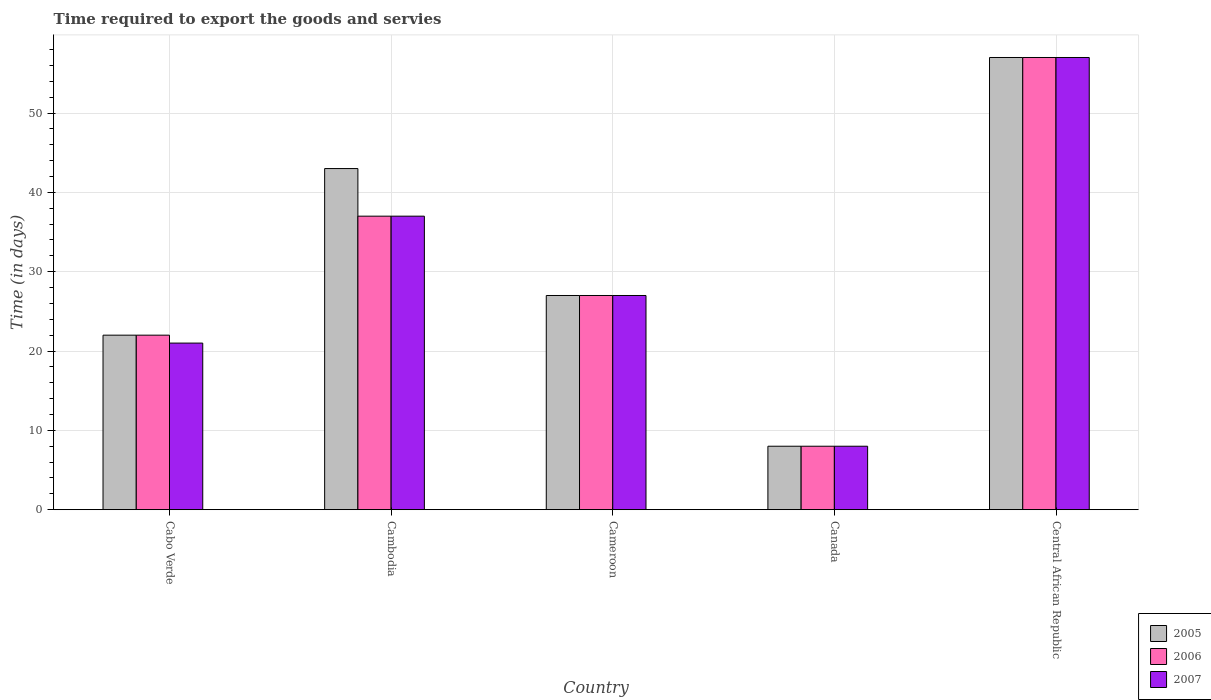How many different coloured bars are there?
Make the answer very short. 3. How many groups of bars are there?
Offer a terse response. 5. Are the number of bars on each tick of the X-axis equal?
Provide a short and direct response. Yes. How many bars are there on the 1st tick from the right?
Offer a very short reply. 3. What is the label of the 2nd group of bars from the left?
Provide a short and direct response. Cambodia. In how many cases, is the number of bars for a given country not equal to the number of legend labels?
Your response must be concise. 0. What is the number of days required to export the goods and services in 2006 in Cabo Verde?
Your answer should be very brief. 22. Across all countries, what is the maximum number of days required to export the goods and services in 2005?
Ensure brevity in your answer.  57. In which country was the number of days required to export the goods and services in 2006 maximum?
Provide a succinct answer. Central African Republic. What is the total number of days required to export the goods and services in 2006 in the graph?
Provide a short and direct response. 151. What is the average number of days required to export the goods and services in 2006 per country?
Give a very brief answer. 30.2. In how many countries, is the number of days required to export the goods and services in 2007 greater than 26 days?
Offer a terse response. 3. What is the ratio of the number of days required to export the goods and services in 2006 in Cabo Verde to that in Cameroon?
Your answer should be very brief. 0.81. Is the difference between the number of days required to export the goods and services in 2007 in Cabo Verde and Canada greater than the difference between the number of days required to export the goods and services in 2005 in Cabo Verde and Canada?
Offer a terse response. No. In how many countries, is the number of days required to export the goods and services in 2005 greater than the average number of days required to export the goods and services in 2005 taken over all countries?
Give a very brief answer. 2. Is it the case that in every country, the sum of the number of days required to export the goods and services in 2006 and number of days required to export the goods and services in 2007 is greater than the number of days required to export the goods and services in 2005?
Give a very brief answer. Yes. What is the difference between two consecutive major ticks on the Y-axis?
Keep it short and to the point. 10. Does the graph contain any zero values?
Your response must be concise. No. How many legend labels are there?
Provide a succinct answer. 3. How are the legend labels stacked?
Offer a terse response. Vertical. What is the title of the graph?
Provide a short and direct response. Time required to export the goods and servies. Does "2001" appear as one of the legend labels in the graph?
Give a very brief answer. No. What is the label or title of the Y-axis?
Your response must be concise. Time (in days). What is the Time (in days) in 2005 in Cabo Verde?
Provide a short and direct response. 22. What is the Time (in days) in 2005 in Cambodia?
Provide a succinct answer. 43. What is the Time (in days) of 2006 in Cambodia?
Ensure brevity in your answer.  37. What is the Time (in days) in 2005 in Cameroon?
Your answer should be compact. 27. What is the Time (in days) in 2006 in Cameroon?
Give a very brief answer. 27. What is the Time (in days) of 2005 in Central African Republic?
Offer a very short reply. 57. What is the Time (in days) in 2007 in Central African Republic?
Give a very brief answer. 57. Across all countries, what is the maximum Time (in days) of 2007?
Offer a very short reply. 57. Across all countries, what is the minimum Time (in days) in 2006?
Your answer should be compact. 8. What is the total Time (in days) of 2005 in the graph?
Make the answer very short. 157. What is the total Time (in days) in 2006 in the graph?
Your answer should be compact. 151. What is the total Time (in days) in 2007 in the graph?
Keep it short and to the point. 150. What is the difference between the Time (in days) in 2006 in Cabo Verde and that in Cambodia?
Provide a succinct answer. -15. What is the difference between the Time (in days) of 2005 in Cabo Verde and that in Cameroon?
Keep it short and to the point. -5. What is the difference between the Time (in days) of 2005 in Cabo Verde and that in Canada?
Provide a short and direct response. 14. What is the difference between the Time (in days) of 2006 in Cabo Verde and that in Canada?
Offer a terse response. 14. What is the difference between the Time (in days) of 2005 in Cabo Verde and that in Central African Republic?
Your answer should be very brief. -35. What is the difference between the Time (in days) in 2006 in Cabo Verde and that in Central African Republic?
Your answer should be compact. -35. What is the difference between the Time (in days) in 2007 in Cabo Verde and that in Central African Republic?
Offer a terse response. -36. What is the difference between the Time (in days) of 2005 in Cambodia and that in Cameroon?
Offer a terse response. 16. What is the difference between the Time (in days) of 2006 in Cambodia and that in Cameroon?
Offer a very short reply. 10. What is the difference between the Time (in days) of 2006 in Cambodia and that in Canada?
Your answer should be very brief. 29. What is the difference between the Time (in days) of 2005 in Cambodia and that in Central African Republic?
Offer a terse response. -14. What is the difference between the Time (in days) of 2006 in Cambodia and that in Central African Republic?
Your response must be concise. -20. What is the difference between the Time (in days) in 2005 in Cameroon and that in Canada?
Your response must be concise. 19. What is the difference between the Time (in days) in 2006 in Cameroon and that in Canada?
Offer a terse response. 19. What is the difference between the Time (in days) of 2005 in Cameroon and that in Central African Republic?
Provide a succinct answer. -30. What is the difference between the Time (in days) of 2005 in Canada and that in Central African Republic?
Ensure brevity in your answer.  -49. What is the difference between the Time (in days) in 2006 in Canada and that in Central African Republic?
Offer a very short reply. -49. What is the difference between the Time (in days) in 2007 in Canada and that in Central African Republic?
Your answer should be compact. -49. What is the difference between the Time (in days) in 2005 in Cabo Verde and the Time (in days) in 2007 in Cambodia?
Make the answer very short. -15. What is the difference between the Time (in days) in 2006 in Cabo Verde and the Time (in days) in 2007 in Cambodia?
Your answer should be very brief. -15. What is the difference between the Time (in days) of 2005 in Cabo Verde and the Time (in days) of 2007 in Cameroon?
Your response must be concise. -5. What is the difference between the Time (in days) in 2005 in Cabo Verde and the Time (in days) in 2006 in Canada?
Provide a short and direct response. 14. What is the difference between the Time (in days) of 2005 in Cabo Verde and the Time (in days) of 2007 in Canada?
Ensure brevity in your answer.  14. What is the difference between the Time (in days) in 2006 in Cabo Verde and the Time (in days) in 2007 in Canada?
Ensure brevity in your answer.  14. What is the difference between the Time (in days) of 2005 in Cabo Verde and the Time (in days) of 2006 in Central African Republic?
Your answer should be compact. -35. What is the difference between the Time (in days) in 2005 in Cabo Verde and the Time (in days) in 2007 in Central African Republic?
Provide a succinct answer. -35. What is the difference between the Time (in days) in 2006 in Cabo Verde and the Time (in days) in 2007 in Central African Republic?
Provide a short and direct response. -35. What is the difference between the Time (in days) in 2005 in Cambodia and the Time (in days) in 2007 in Cameroon?
Offer a terse response. 16. What is the difference between the Time (in days) of 2006 in Cambodia and the Time (in days) of 2007 in Cameroon?
Ensure brevity in your answer.  10. What is the difference between the Time (in days) in 2005 in Cambodia and the Time (in days) in 2006 in Canada?
Provide a short and direct response. 35. What is the difference between the Time (in days) of 2005 in Cambodia and the Time (in days) of 2007 in Canada?
Offer a terse response. 35. What is the difference between the Time (in days) of 2005 in Cambodia and the Time (in days) of 2007 in Central African Republic?
Offer a very short reply. -14. What is the difference between the Time (in days) in 2006 in Cambodia and the Time (in days) in 2007 in Central African Republic?
Your answer should be very brief. -20. What is the difference between the Time (in days) in 2005 in Cameroon and the Time (in days) in 2006 in Central African Republic?
Provide a short and direct response. -30. What is the difference between the Time (in days) in 2005 in Cameroon and the Time (in days) in 2007 in Central African Republic?
Your response must be concise. -30. What is the difference between the Time (in days) in 2005 in Canada and the Time (in days) in 2006 in Central African Republic?
Your answer should be compact. -49. What is the difference between the Time (in days) of 2005 in Canada and the Time (in days) of 2007 in Central African Republic?
Give a very brief answer. -49. What is the difference between the Time (in days) of 2006 in Canada and the Time (in days) of 2007 in Central African Republic?
Your answer should be very brief. -49. What is the average Time (in days) in 2005 per country?
Provide a short and direct response. 31.4. What is the average Time (in days) in 2006 per country?
Offer a terse response. 30.2. What is the average Time (in days) of 2007 per country?
Make the answer very short. 30. What is the difference between the Time (in days) in 2005 and Time (in days) in 2006 in Cabo Verde?
Provide a short and direct response. 0. What is the difference between the Time (in days) of 2006 and Time (in days) of 2007 in Cabo Verde?
Your answer should be compact. 1. What is the difference between the Time (in days) in 2005 and Time (in days) in 2006 in Cambodia?
Give a very brief answer. 6. What is the difference between the Time (in days) of 2005 and Time (in days) of 2007 in Cambodia?
Give a very brief answer. 6. What is the difference between the Time (in days) of 2005 and Time (in days) of 2006 in Cameroon?
Your answer should be compact. 0. What is the difference between the Time (in days) in 2006 and Time (in days) in 2007 in Cameroon?
Provide a succinct answer. 0. What is the difference between the Time (in days) of 2005 and Time (in days) of 2007 in Canada?
Ensure brevity in your answer.  0. What is the difference between the Time (in days) of 2005 and Time (in days) of 2006 in Central African Republic?
Make the answer very short. 0. What is the difference between the Time (in days) in 2005 and Time (in days) in 2007 in Central African Republic?
Your answer should be very brief. 0. What is the ratio of the Time (in days) in 2005 in Cabo Verde to that in Cambodia?
Your answer should be very brief. 0.51. What is the ratio of the Time (in days) of 2006 in Cabo Verde to that in Cambodia?
Offer a terse response. 0.59. What is the ratio of the Time (in days) of 2007 in Cabo Verde to that in Cambodia?
Keep it short and to the point. 0.57. What is the ratio of the Time (in days) in 2005 in Cabo Verde to that in Cameroon?
Your response must be concise. 0.81. What is the ratio of the Time (in days) of 2006 in Cabo Verde to that in Cameroon?
Make the answer very short. 0.81. What is the ratio of the Time (in days) in 2007 in Cabo Verde to that in Cameroon?
Your answer should be compact. 0.78. What is the ratio of the Time (in days) of 2005 in Cabo Verde to that in Canada?
Ensure brevity in your answer.  2.75. What is the ratio of the Time (in days) of 2006 in Cabo Verde to that in Canada?
Offer a very short reply. 2.75. What is the ratio of the Time (in days) in 2007 in Cabo Verde to that in Canada?
Provide a succinct answer. 2.62. What is the ratio of the Time (in days) of 2005 in Cabo Verde to that in Central African Republic?
Ensure brevity in your answer.  0.39. What is the ratio of the Time (in days) in 2006 in Cabo Verde to that in Central African Republic?
Give a very brief answer. 0.39. What is the ratio of the Time (in days) in 2007 in Cabo Verde to that in Central African Republic?
Keep it short and to the point. 0.37. What is the ratio of the Time (in days) of 2005 in Cambodia to that in Cameroon?
Offer a terse response. 1.59. What is the ratio of the Time (in days) of 2006 in Cambodia to that in Cameroon?
Provide a succinct answer. 1.37. What is the ratio of the Time (in days) of 2007 in Cambodia to that in Cameroon?
Provide a short and direct response. 1.37. What is the ratio of the Time (in days) of 2005 in Cambodia to that in Canada?
Provide a succinct answer. 5.38. What is the ratio of the Time (in days) in 2006 in Cambodia to that in Canada?
Provide a succinct answer. 4.62. What is the ratio of the Time (in days) of 2007 in Cambodia to that in Canada?
Provide a short and direct response. 4.62. What is the ratio of the Time (in days) of 2005 in Cambodia to that in Central African Republic?
Keep it short and to the point. 0.75. What is the ratio of the Time (in days) in 2006 in Cambodia to that in Central African Republic?
Your answer should be very brief. 0.65. What is the ratio of the Time (in days) of 2007 in Cambodia to that in Central African Republic?
Your response must be concise. 0.65. What is the ratio of the Time (in days) of 2005 in Cameroon to that in Canada?
Offer a very short reply. 3.38. What is the ratio of the Time (in days) in 2006 in Cameroon to that in Canada?
Ensure brevity in your answer.  3.38. What is the ratio of the Time (in days) in 2007 in Cameroon to that in Canada?
Your response must be concise. 3.38. What is the ratio of the Time (in days) of 2005 in Cameroon to that in Central African Republic?
Provide a succinct answer. 0.47. What is the ratio of the Time (in days) in 2006 in Cameroon to that in Central African Republic?
Provide a succinct answer. 0.47. What is the ratio of the Time (in days) in 2007 in Cameroon to that in Central African Republic?
Provide a short and direct response. 0.47. What is the ratio of the Time (in days) in 2005 in Canada to that in Central African Republic?
Ensure brevity in your answer.  0.14. What is the ratio of the Time (in days) of 2006 in Canada to that in Central African Republic?
Your answer should be compact. 0.14. What is the ratio of the Time (in days) in 2007 in Canada to that in Central African Republic?
Your response must be concise. 0.14. What is the difference between the highest and the lowest Time (in days) of 2006?
Your answer should be very brief. 49. 